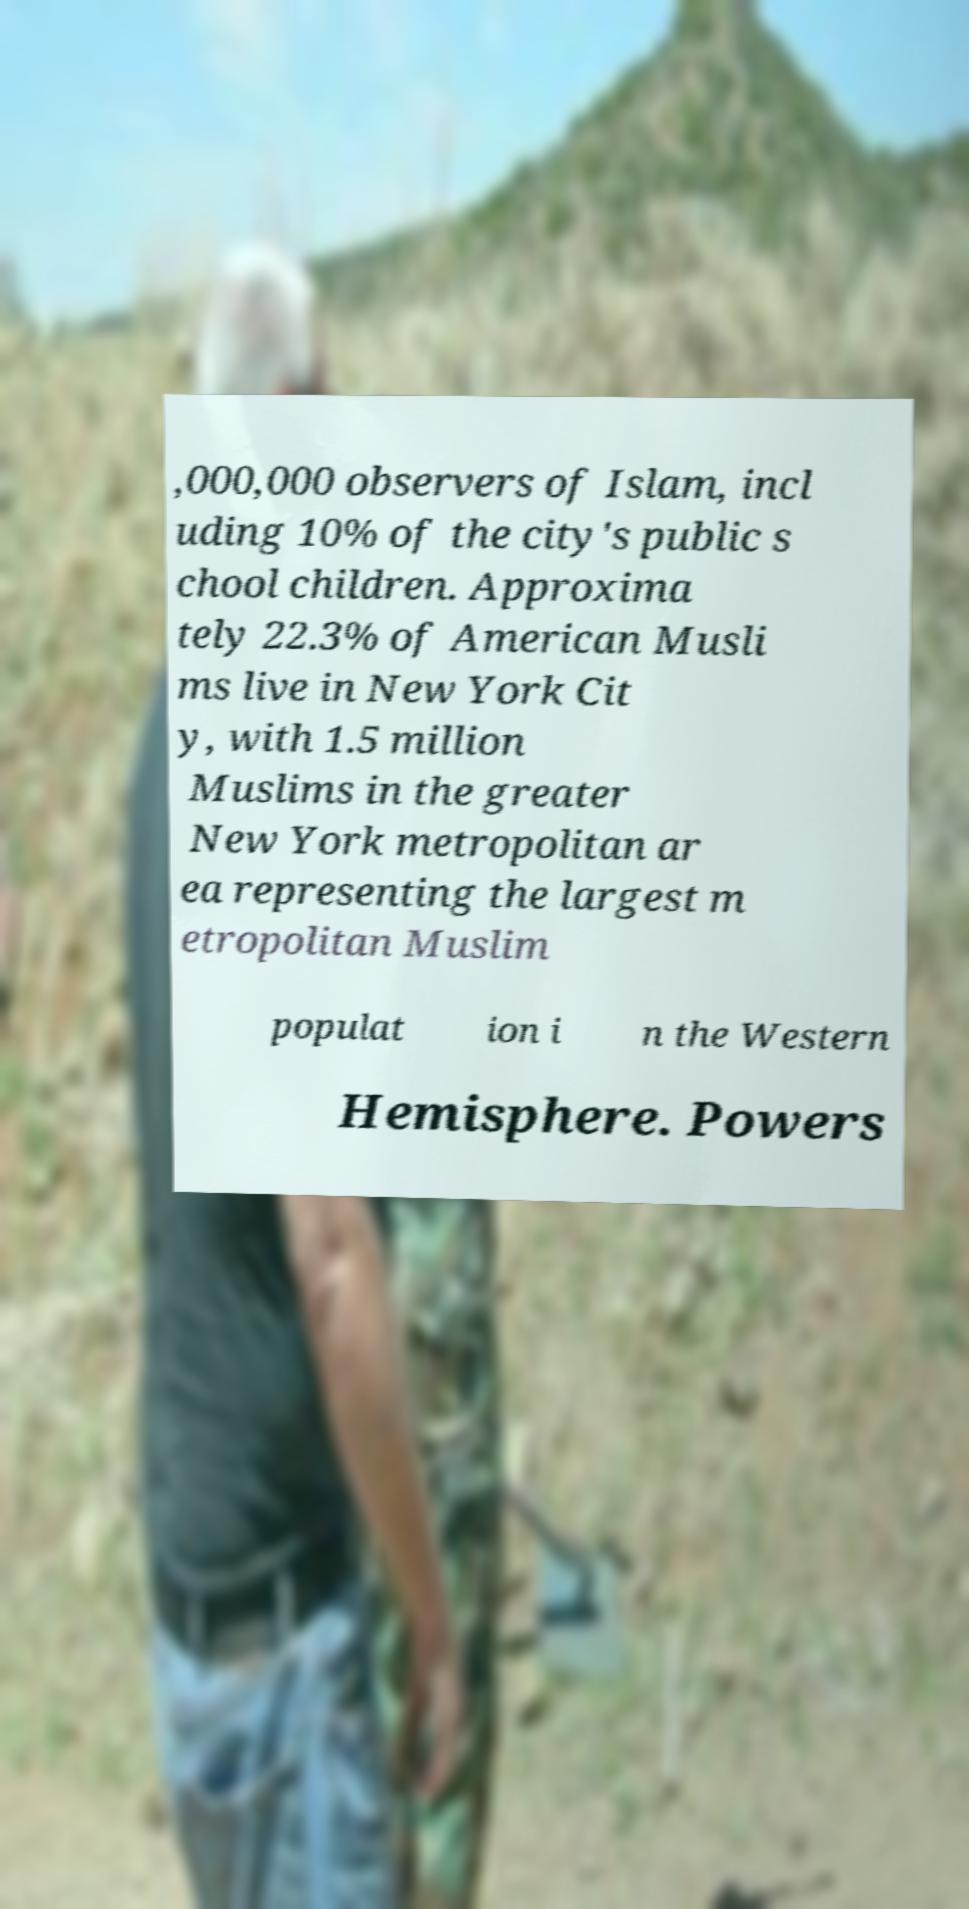I need the written content from this picture converted into text. Can you do that? ,000,000 observers of Islam, incl uding 10% of the city's public s chool children. Approxima tely 22.3% of American Musli ms live in New York Cit y, with 1.5 million Muslims in the greater New York metropolitan ar ea representing the largest m etropolitan Muslim populat ion i n the Western Hemisphere. Powers 